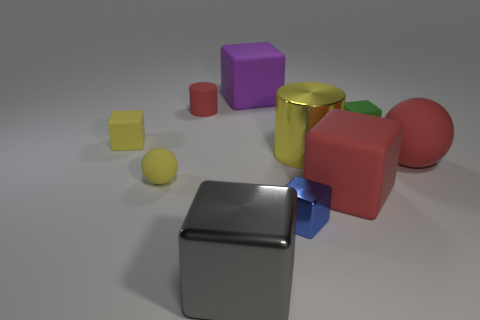The matte block that is the same color as the big metal cylinder is what size?
Keep it short and to the point. Small. What is the material of the block that is the same color as the big rubber sphere?
Provide a succinct answer. Rubber. What number of other things are there of the same color as the small sphere?
Offer a very short reply. 2. Is the material of the big yellow thing the same as the tiny cube that is left of the gray cube?
Offer a terse response. No. There is a small matte block that is on the left side of the red rubber object that is behind the small yellow matte block; how many red rubber cylinders are on the right side of it?
Your answer should be very brief. 1. Is the number of tiny yellow spheres behind the small red matte thing less than the number of large gray metal blocks behind the large gray thing?
Keep it short and to the point. No. How many other objects are there of the same material as the small blue object?
Offer a terse response. 2. There is a yellow cube that is the same size as the blue cube; what material is it?
Make the answer very short. Rubber. What number of gray objects are either large spheres or small rubber cylinders?
Ensure brevity in your answer.  0. The big cube that is both behind the small blue shiny block and left of the blue metallic object is what color?
Provide a short and direct response. Purple. 